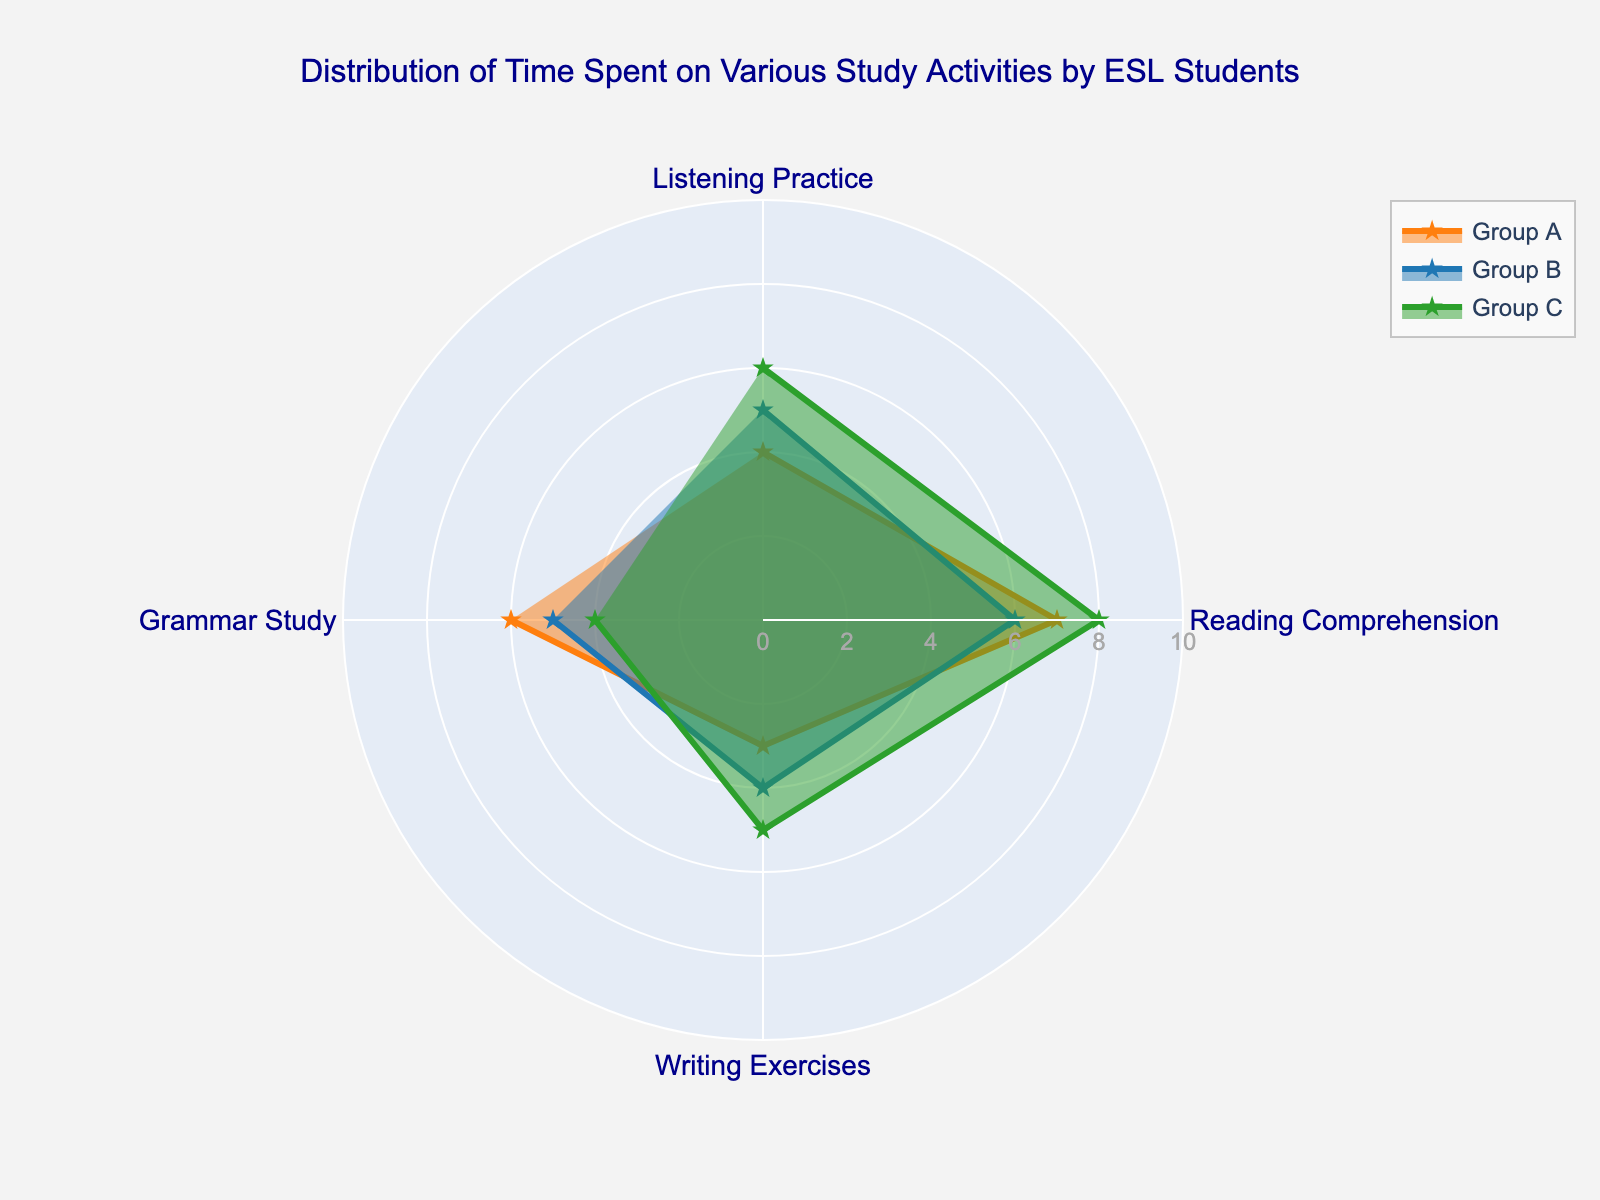What's the highest value in Group A? To find the highest value in Group A, look at the scores for each activity. The highest values are in Reading Comprehension with 7
Answer: 7 What color is used to represent Group B? Identify the color used for the line and marker representing Group B. Group B is associated with a blue color.
Answer: Blue Which group spends the most time on Writing Exercises? Compare the Writing Exercises values for each group. Group C has the highest value at 5.
Answer: Group C Calculate the difference in Grammar Study time between Group A and Group B. Subtract the value for Group B from the value for Group A for Grammar Study. 6 (Group A) - 5 (Group B) = 1
Answer: 1 Which activity has the most variation in time spent among all groups? Calculate the range (difference between the highest and lowest values) for each activity. Reading Comprehension has the most variation with a range of 8 (Group C) - 6 (Group B) = 2.
Answer: Reading Comprehension How many activities are measured in the chart? Count the number of axes or categories labeled around the radar chart. There are 4 activities measured.
Answer: 4 Which group has the lowest average time spent across all activities? Calculate the average for each group. Group A: (4+7+3+6)/4 = 5, Group B: (5+6+4+5)/4 = 5, Group C: (6+8+5+4)/4 = 5.25. So, both Group A and Group B have the lowest at 5.
Answer: Group A and Group B Which group spends the least time on Listening Practice? Compare the Listening Practice values for each group. Group A spends the least time with a value of 4.
Answer: Group A Is there any group that spends equal time on two different activities? Look at each group's values to see if any two activities have the same score. Group B spends the same amount of time on Grammar Study and Writing Exercises, both at 5.
Answer: Group B Which group spends more time on Grammar Study than Reading Comprehension? Compare the values for Grammar Study and Reading Comprehension within each group. No groups spend more time on Grammar Study than Reading Comprehension.
Answer: None 